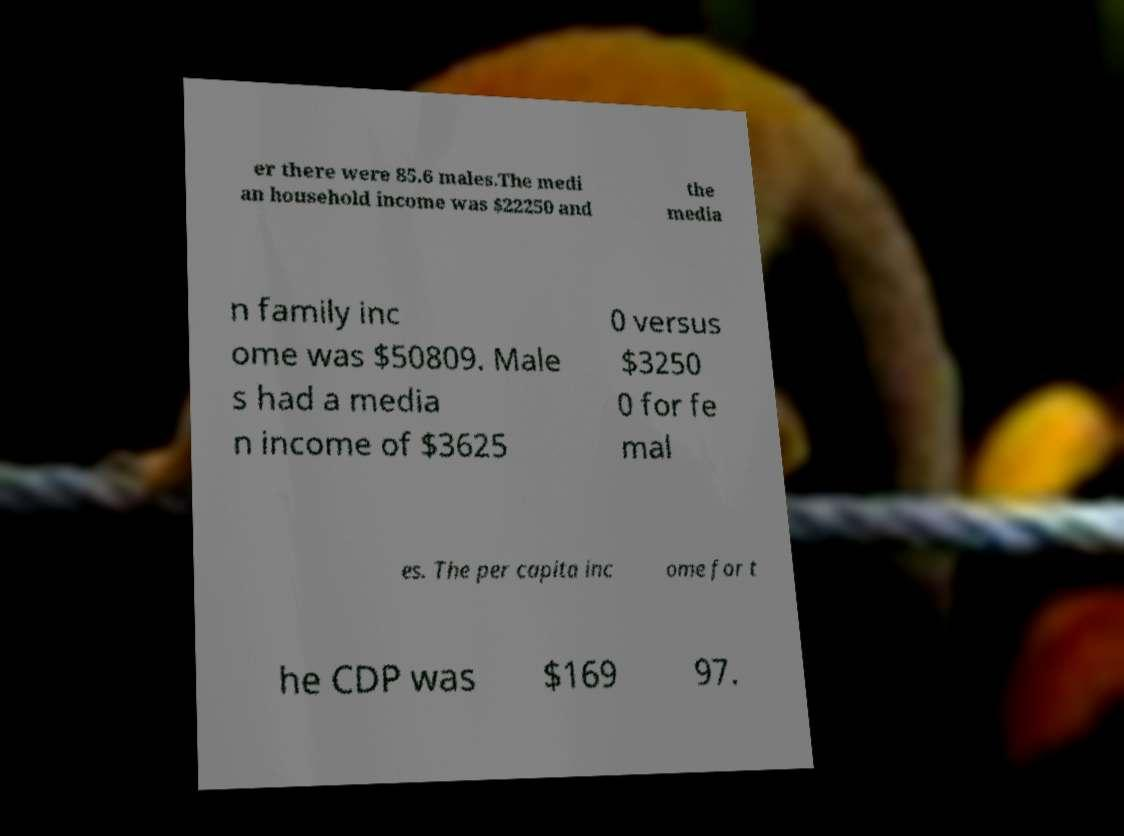Can you accurately transcribe the text from the provided image for me? er there were 85.6 males.The medi an household income was $22250 and the media n family inc ome was $50809. Male s had a media n income of $3625 0 versus $3250 0 for fe mal es. The per capita inc ome for t he CDP was $169 97. 